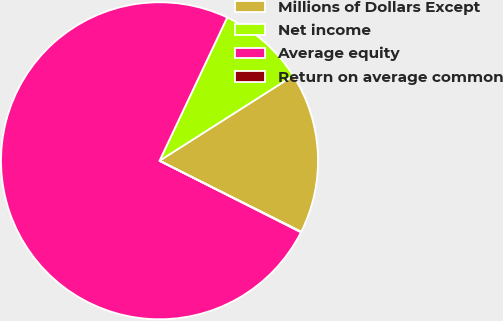Convert chart to OTSL. <chart><loc_0><loc_0><loc_500><loc_500><pie_chart><fcel>Millions of Dollars Except<fcel>Net income<fcel>Average equity<fcel>Return on average common<nl><fcel>16.41%<fcel>8.96%<fcel>74.58%<fcel>0.06%<nl></chart> 